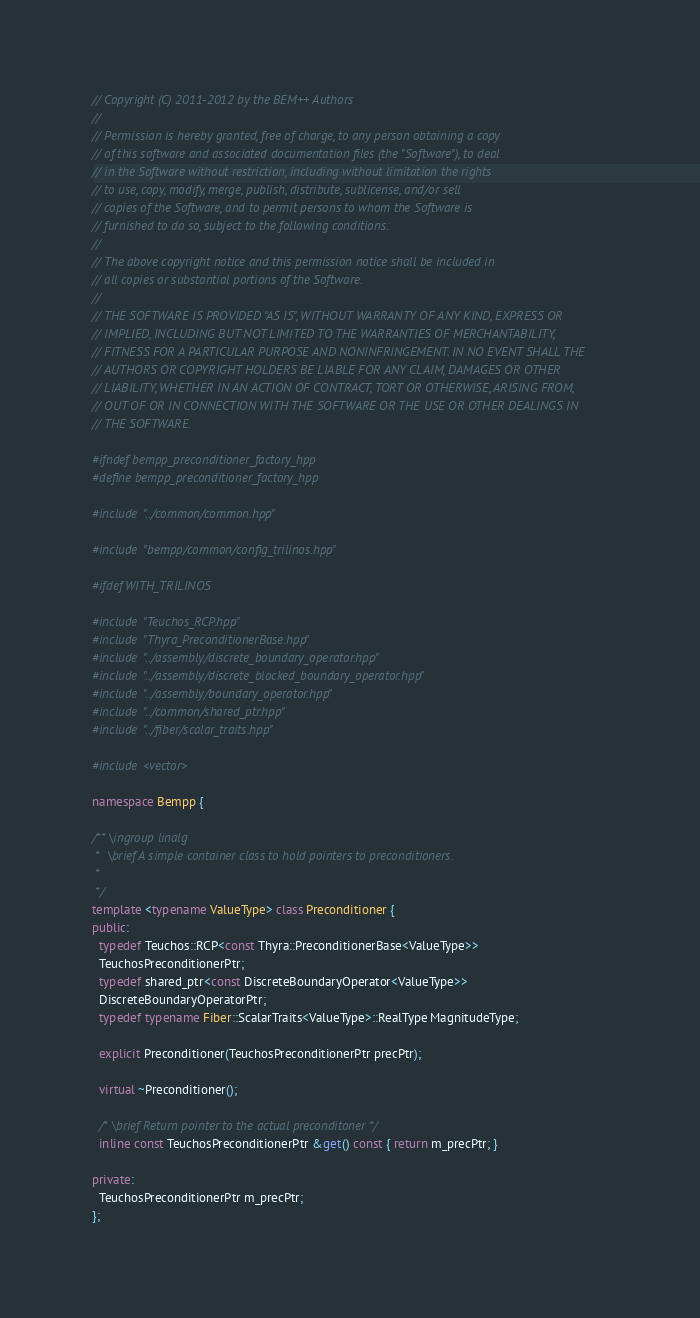Convert code to text. <code><loc_0><loc_0><loc_500><loc_500><_C++_>// Copyright (C) 2011-2012 by the BEM++ Authors
//
// Permission is hereby granted, free of charge, to any person obtaining a copy
// of this software and associated documentation files (the "Software"), to deal
// in the Software without restriction, including without limitation the rights
// to use, copy, modify, merge, publish, distribute, sublicense, and/or sell
// copies of the Software, and to permit persons to whom the Software is
// furnished to do so, subject to the following conditions:
//
// The above copyright notice and this permission notice shall be included in
// all copies or substantial portions of the Software.
//
// THE SOFTWARE IS PROVIDED "AS IS", WITHOUT WARRANTY OF ANY KIND, EXPRESS OR
// IMPLIED, INCLUDING BUT NOT LIMITED TO THE WARRANTIES OF MERCHANTABILITY,
// FITNESS FOR A PARTICULAR PURPOSE AND NONINFRINGEMENT. IN NO EVENT SHALL THE
// AUTHORS OR COPYRIGHT HOLDERS BE LIABLE FOR ANY CLAIM, DAMAGES OR OTHER
// LIABILITY, WHETHER IN AN ACTION OF CONTRACT, TORT OR OTHERWISE, ARISING FROM,
// OUT OF OR IN CONNECTION WITH THE SOFTWARE OR THE USE OR OTHER DEALINGS IN
// THE SOFTWARE.

#ifndef bempp_preconditioner_factory_hpp
#define bempp_preconditioner_factory_hpp

#include "../common/common.hpp"

#include "bempp/common/config_trilinos.hpp"

#ifdef WITH_TRILINOS

#include "Teuchos_RCP.hpp"
#include "Thyra_PreconditionerBase.hpp"
#include "../assembly/discrete_boundary_operator.hpp"
#include "../assembly/discrete_blocked_boundary_operator.hpp"
#include "../assembly/boundary_operator.hpp"
#include "../common/shared_ptr.hpp"
#include "../fiber/scalar_traits.hpp"

#include <vector>

namespace Bempp {

/** \ingroup linalg
 *  \brief A simple container class to hold pointers to preconditioners.
 *
 */
template <typename ValueType> class Preconditioner {
public:
  typedef Teuchos::RCP<const Thyra::PreconditionerBase<ValueType>>
  TeuchosPreconditionerPtr;
  typedef shared_ptr<const DiscreteBoundaryOperator<ValueType>>
  DiscreteBoundaryOperatorPtr;
  typedef typename Fiber::ScalarTraits<ValueType>::RealType MagnitudeType;

  explicit Preconditioner(TeuchosPreconditionerPtr precPtr);

  virtual ~Preconditioner();

  /* \brief Return pointer to the actual preconditoner */
  inline const TeuchosPreconditionerPtr &get() const { return m_precPtr; }

private:
  TeuchosPreconditionerPtr m_precPtr;
};
</code> 